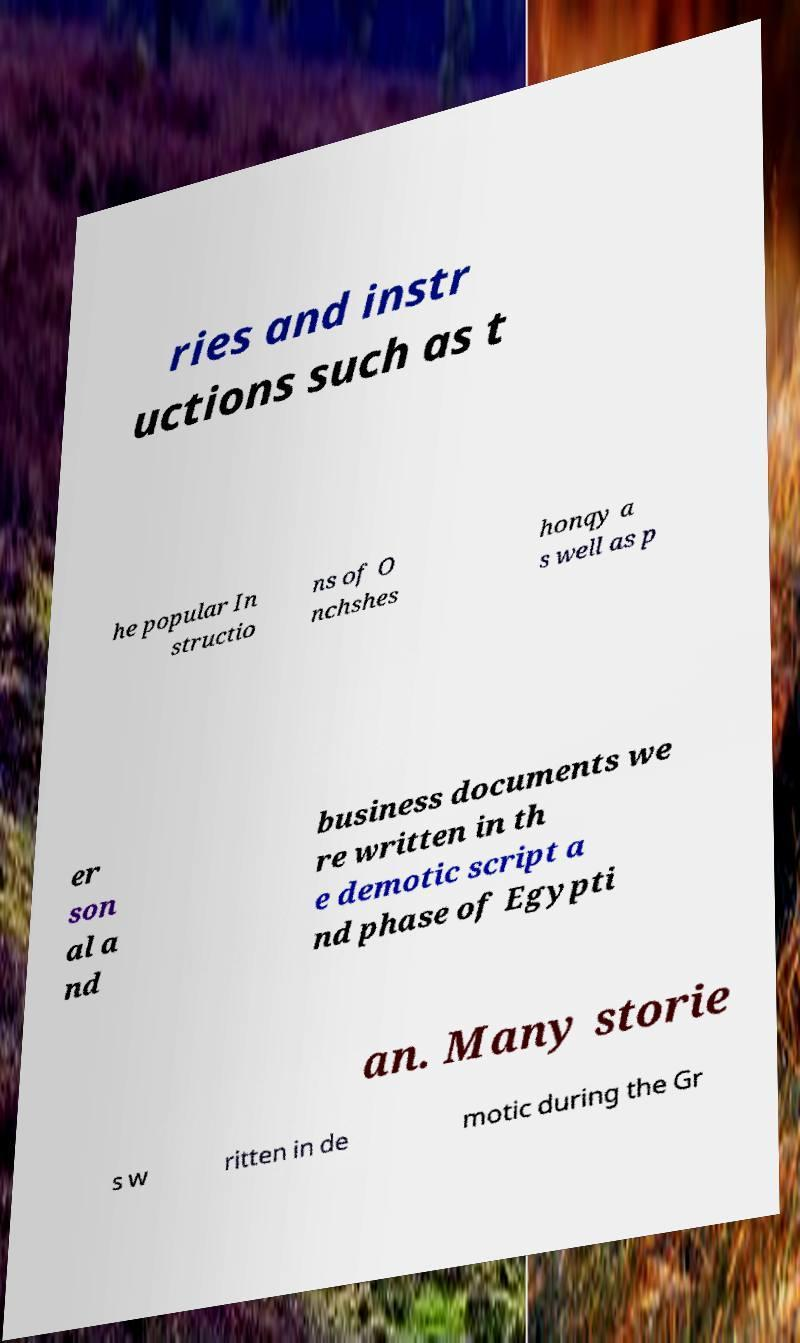Please read and relay the text visible in this image. What does it say? ries and instr uctions such as t he popular In structio ns of O nchshes honqy a s well as p er son al a nd business documents we re written in th e demotic script a nd phase of Egypti an. Many storie s w ritten in de motic during the Gr 